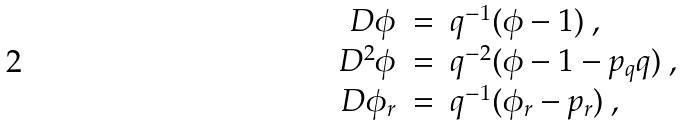Convert formula to latex. <formula><loc_0><loc_0><loc_500><loc_500>\begin{array} { r c l } \ D \phi & = & q ^ { - 1 } ( \phi - 1 ) \ , \\ \ D ^ { 2 } \phi & = & q ^ { - 2 } ( \phi - 1 - p _ { q } q ) \ , \\ \ D \phi _ { r } & = & q ^ { - 1 } ( \phi _ { r } - p _ { r } ) \ , \end{array}</formula> 